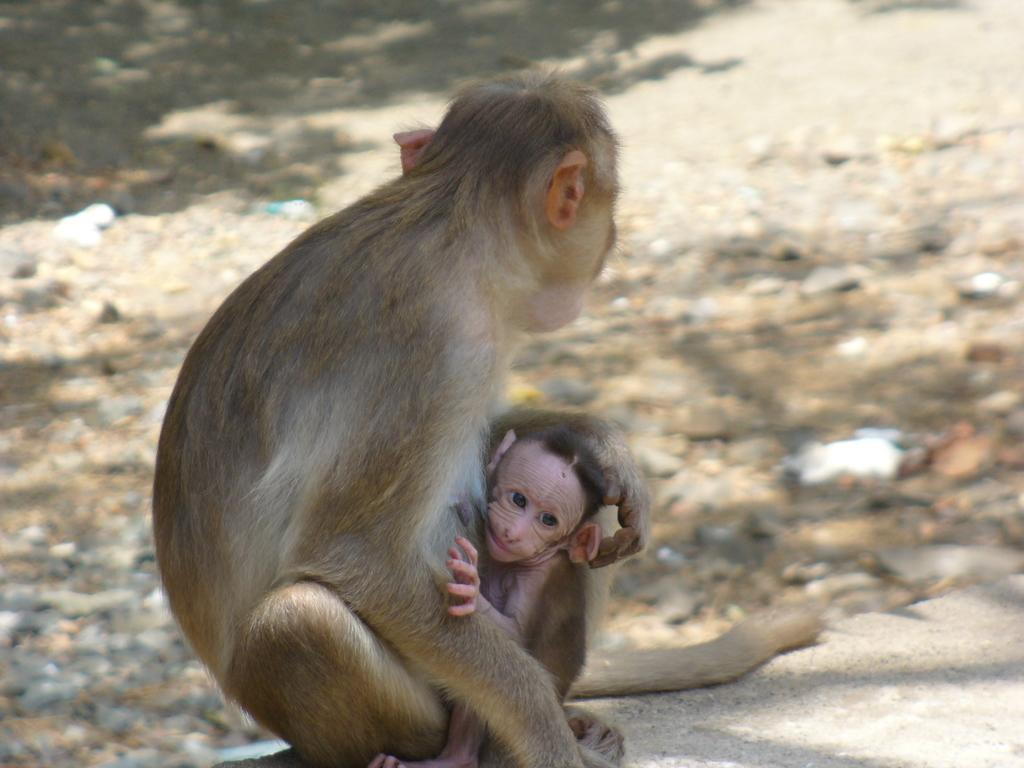What type of animal is in the image? There is a monkey in the image. Can you describe the monkey in the image? There is an infant monkey in the image. What can be seen in the background of the image? The background of the image includes land. What type of birthday cake is being served to the monkey in the image? There is no birthday cake or any indication of a birthday celebration in the image. 